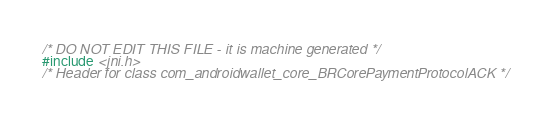Convert code to text. <code><loc_0><loc_0><loc_500><loc_500><_C_>/* DO NOT EDIT THIS FILE - it is machine generated */
#include <jni.h>
/* Header for class com_androidwallet_core_BRCorePaymentProtocolACK */
</code> 